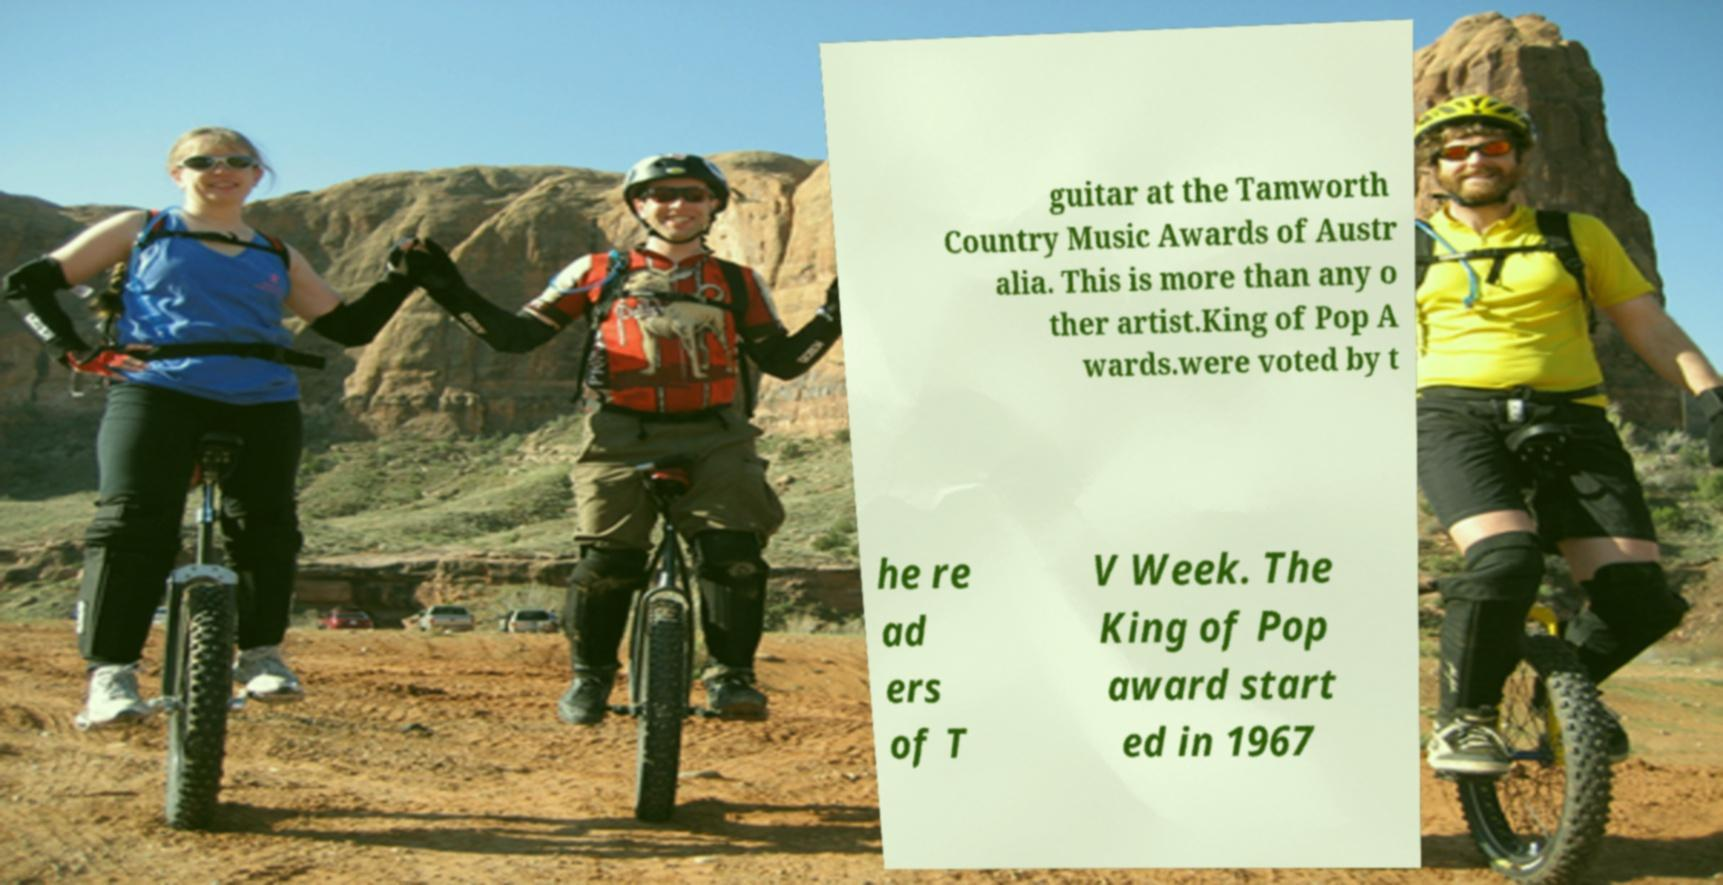For documentation purposes, I need the text within this image transcribed. Could you provide that? guitar at the Tamworth Country Music Awards of Austr alia. This is more than any o ther artist.King of Pop A wards.were voted by t he re ad ers of T V Week. The King of Pop award start ed in 1967 